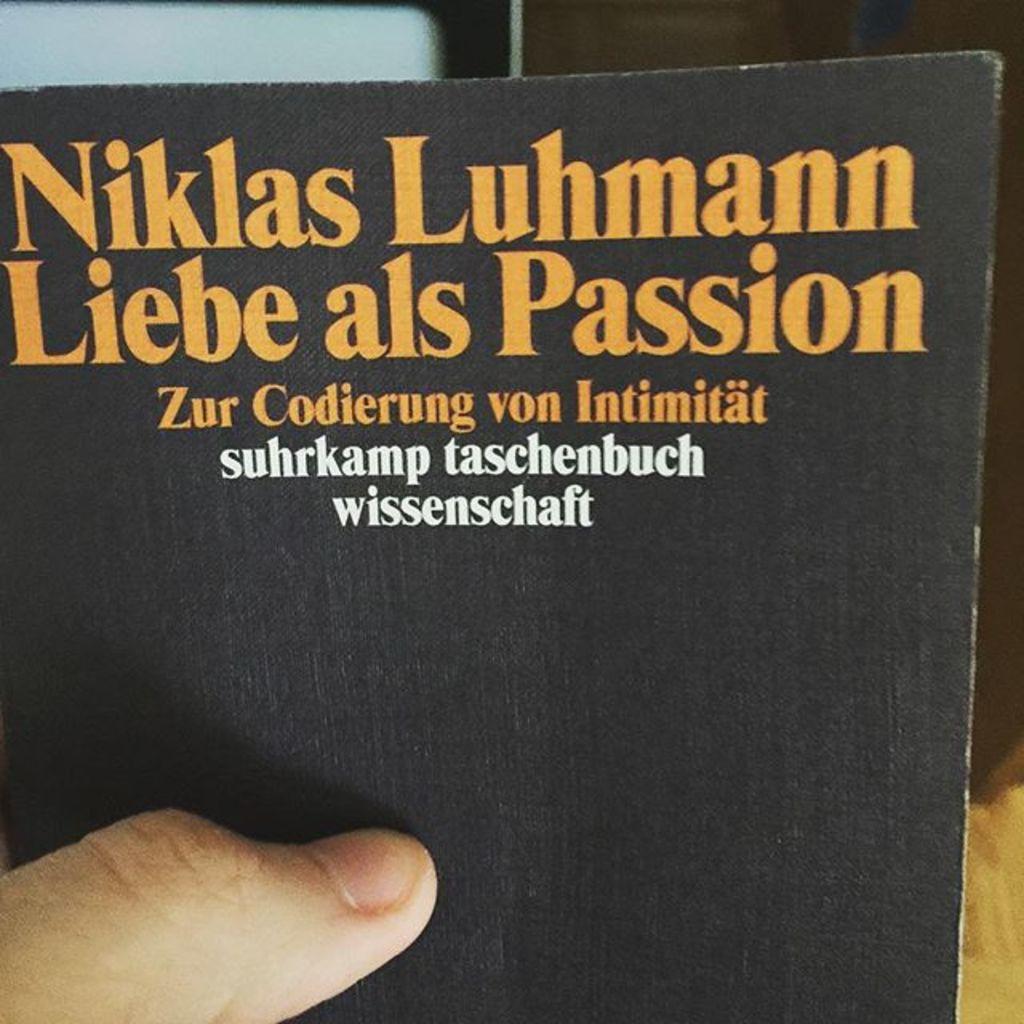What is the title of this book?
Make the answer very short. Niklas luhmann liebe als passion. What is the word written yellow that is also a english word?
Ensure brevity in your answer.  Passion. 